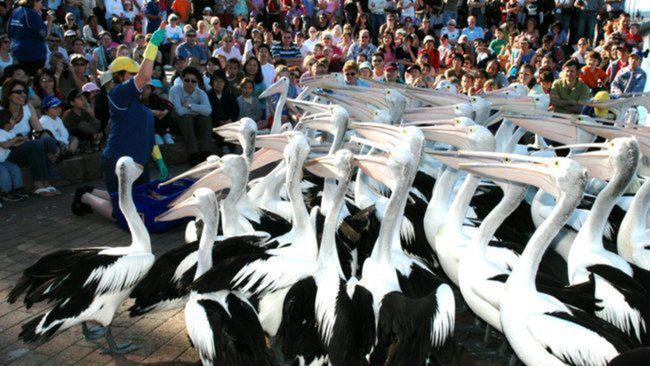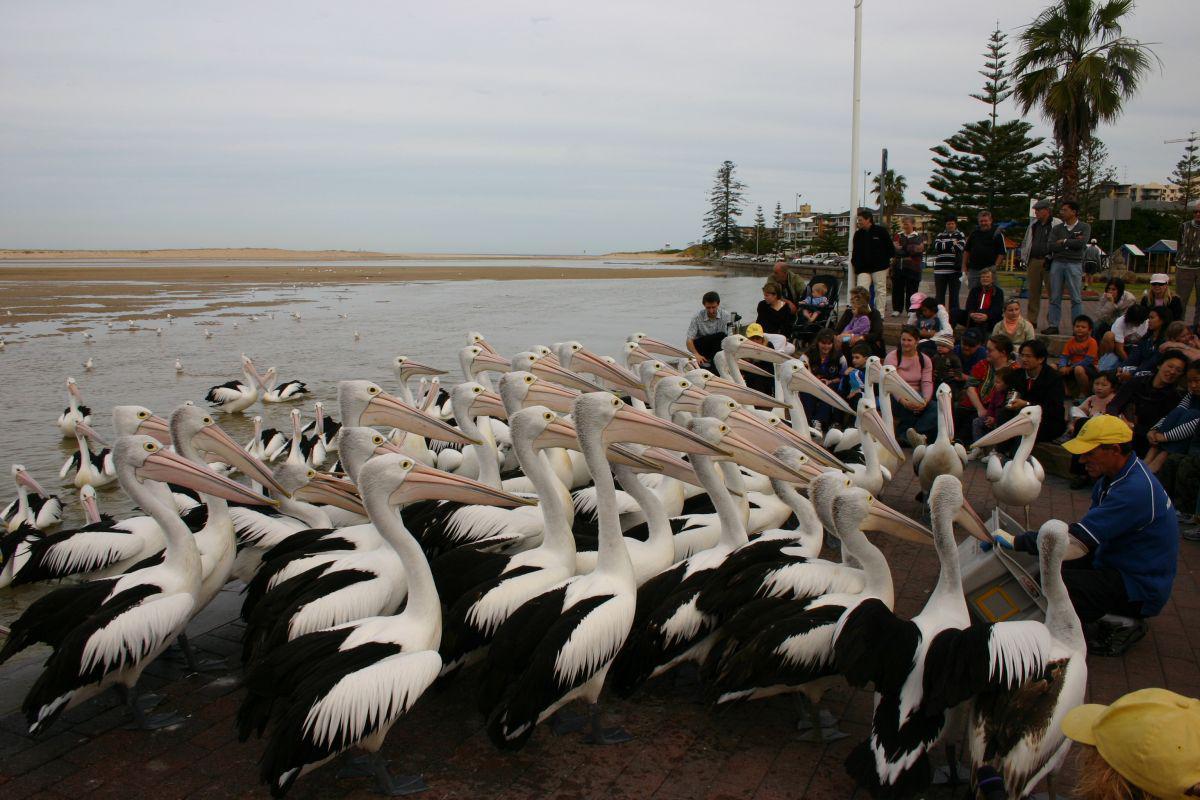The first image is the image on the left, the second image is the image on the right. Given the left and right images, does the statement "There are at least eight pelicans facing left with no more than four people visible in the right side of the photo." hold true? Answer yes or no. No. 